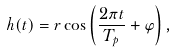Convert formula to latex. <formula><loc_0><loc_0><loc_500><loc_500>h ( t ) = r \cos \left ( \frac { 2 \pi t } { T _ { p } } + \varphi \right ) ,</formula> 